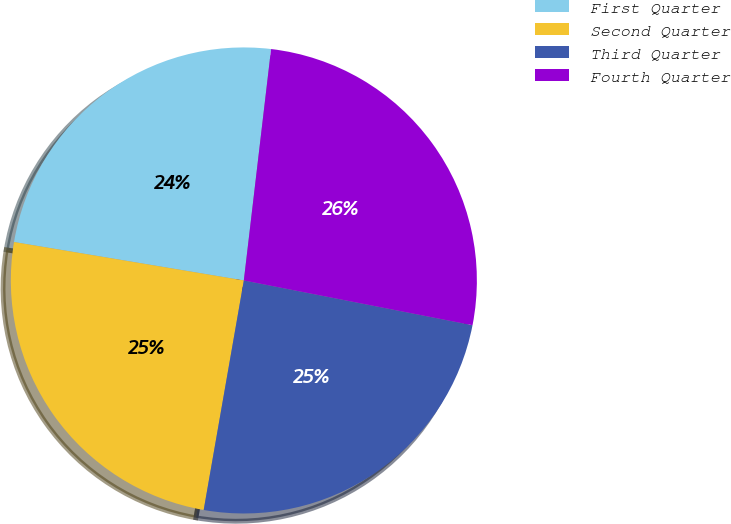Convert chart to OTSL. <chart><loc_0><loc_0><loc_500><loc_500><pie_chart><fcel>First Quarter<fcel>Second Quarter<fcel>Third Quarter<fcel>Fourth Quarter<nl><fcel>24.23%<fcel>24.88%<fcel>24.68%<fcel>26.21%<nl></chart> 